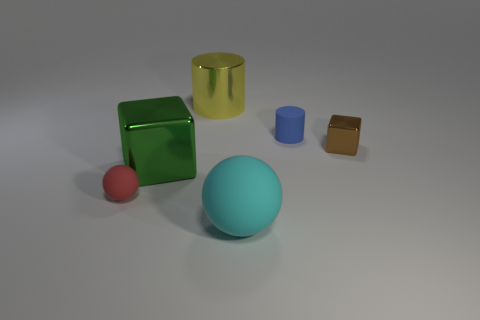There is a tiny blue object that is made of the same material as the big cyan sphere; what shape is it?
Ensure brevity in your answer.  Cylinder. There is a big shiny thing that is behind the large green block; is it the same shape as the cyan object?
Your response must be concise. No. There is a big metallic object that is in front of the yellow shiny object; what shape is it?
Your response must be concise. Cube. What number of brown metallic blocks are the same size as the red matte object?
Your answer should be very brief. 1. What color is the shiny cylinder?
Your answer should be compact. Yellow. There is a big cylinder; is its color the same as the block that is to the left of the matte cylinder?
Ensure brevity in your answer.  No. The yellow object that is the same material as the large green object is what size?
Your answer should be very brief. Large. How many objects are either small things that are left of the yellow thing or purple cylinders?
Your response must be concise. 1. Is the blue cylinder made of the same material as the block left of the blue object?
Provide a short and direct response. No. Are there any small brown blocks that have the same material as the large green object?
Keep it short and to the point. Yes. 